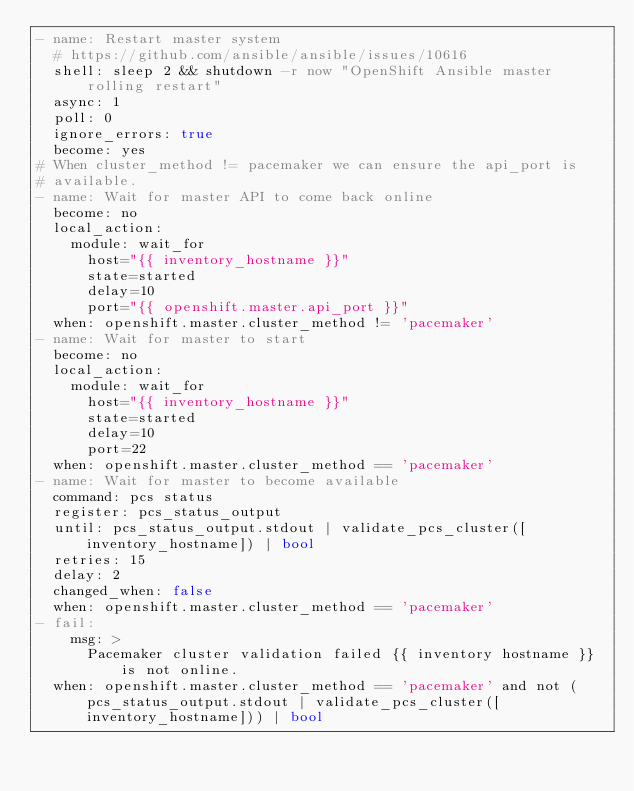Convert code to text. <code><loc_0><loc_0><loc_500><loc_500><_YAML_>- name: Restart master system
  # https://github.com/ansible/ansible/issues/10616
  shell: sleep 2 && shutdown -r now "OpenShift Ansible master rolling restart"
  async: 1
  poll: 0
  ignore_errors: true
  become: yes
# When cluster_method != pacemaker we can ensure the api_port is
# available.
- name: Wait for master API to come back online
  become: no
  local_action:
    module: wait_for
      host="{{ inventory_hostname }}"
      state=started
      delay=10
      port="{{ openshift.master.api_port }}"
  when: openshift.master.cluster_method != 'pacemaker'
- name: Wait for master to start
  become: no
  local_action:
    module: wait_for
      host="{{ inventory_hostname }}"
      state=started
      delay=10
      port=22
  when: openshift.master.cluster_method == 'pacemaker'
- name: Wait for master to become available
  command: pcs status
  register: pcs_status_output
  until: pcs_status_output.stdout | validate_pcs_cluster([inventory_hostname]) | bool
  retries: 15
  delay: 2
  changed_when: false
  when: openshift.master.cluster_method == 'pacemaker'
- fail:
    msg: >
      Pacemaker cluster validation failed {{ inventory hostname }} is not online.
  when: openshift.master.cluster_method == 'pacemaker' and not (pcs_status_output.stdout | validate_pcs_cluster([inventory_hostname])) | bool
</code> 